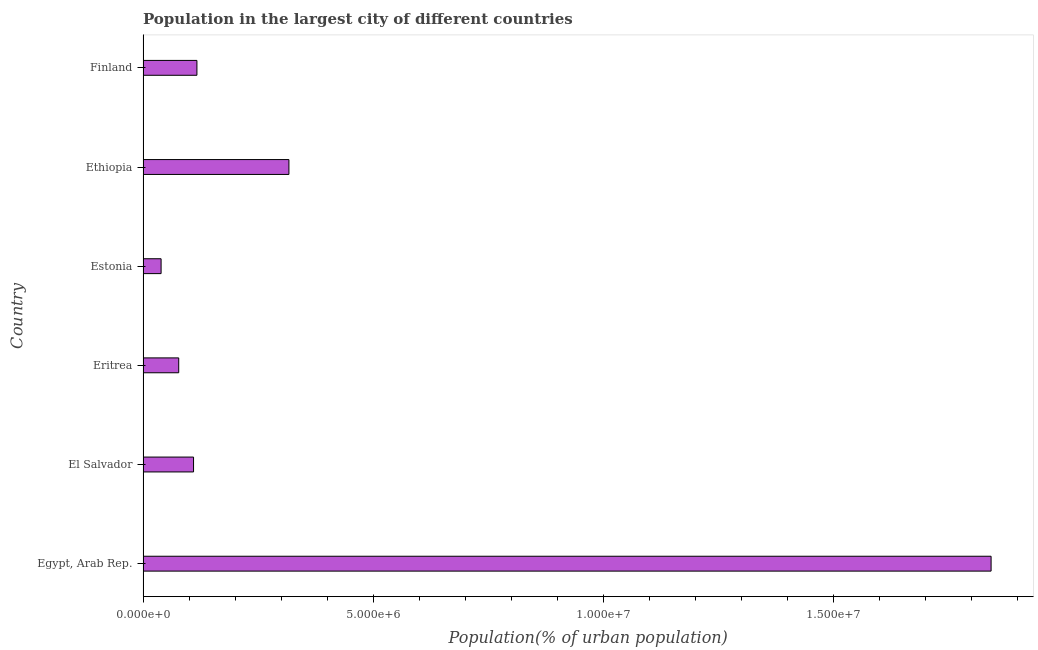Does the graph contain any zero values?
Your answer should be very brief. No. What is the title of the graph?
Your response must be concise. Population in the largest city of different countries. What is the label or title of the X-axis?
Your response must be concise. Population(% of urban population). What is the label or title of the Y-axis?
Keep it short and to the point. Country. What is the population in largest city in El Salvador?
Give a very brief answer. 1.10e+06. Across all countries, what is the maximum population in largest city?
Offer a very short reply. 1.84e+07. Across all countries, what is the minimum population in largest city?
Provide a short and direct response. 3.92e+05. In which country was the population in largest city maximum?
Offer a terse response. Egypt, Arab Rep. In which country was the population in largest city minimum?
Offer a very short reply. Estonia. What is the sum of the population in largest city?
Provide a succinct answer. 2.50e+07. What is the difference between the population in largest city in Egypt, Arab Rep. and El Salvador?
Give a very brief answer. 1.73e+07. What is the average population in largest city per country?
Offer a terse response. 4.17e+06. What is the median population in largest city?
Provide a succinct answer. 1.13e+06. What is the ratio of the population in largest city in Estonia to that in Ethiopia?
Your response must be concise. 0.12. Is the difference between the population in largest city in Egypt, Arab Rep. and Estonia greater than the difference between any two countries?
Keep it short and to the point. Yes. What is the difference between the highest and the second highest population in largest city?
Your response must be concise. 1.53e+07. What is the difference between the highest and the lowest population in largest city?
Keep it short and to the point. 1.80e+07. What is the difference between two consecutive major ticks on the X-axis?
Your response must be concise. 5.00e+06. What is the Population(% of urban population) in Egypt, Arab Rep.?
Your answer should be compact. 1.84e+07. What is the Population(% of urban population) in El Salvador?
Your answer should be compact. 1.10e+06. What is the Population(% of urban population) in Eritrea?
Make the answer very short. 7.75e+05. What is the Population(% of urban population) of Estonia?
Keep it short and to the point. 3.92e+05. What is the Population(% of urban population) in Ethiopia?
Your answer should be very brief. 3.17e+06. What is the Population(% of urban population) in Finland?
Give a very brief answer. 1.17e+06. What is the difference between the Population(% of urban population) in Egypt, Arab Rep. and El Salvador?
Ensure brevity in your answer.  1.73e+07. What is the difference between the Population(% of urban population) in Egypt, Arab Rep. and Eritrea?
Give a very brief answer. 1.76e+07. What is the difference between the Population(% of urban population) in Egypt, Arab Rep. and Estonia?
Make the answer very short. 1.80e+07. What is the difference between the Population(% of urban population) in Egypt, Arab Rep. and Ethiopia?
Keep it short and to the point. 1.53e+07. What is the difference between the Population(% of urban population) in Egypt, Arab Rep. and Finland?
Your answer should be compact. 1.72e+07. What is the difference between the Population(% of urban population) in El Salvador and Eritrea?
Ensure brevity in your answer.  3.22e+05. What is the difference between the Population(% of urban population) in El Salvador and Estonia?
Make the answer very short. 7.05e+05. What is the difference between the Population(% of urban population) in El Salvador and Ethiopia?
Your response must be concise. -2.07e+06. What is the difference between the Population(% of urban population) in El Salvador and Finland?
Your answer should be compact. -7.34e+04. What is the difference between the Population(% of urban population) in Eritrea and Estonia?
Your response must be concise. 3.83e+05. What is the difference between the Population(% of urban population) in Eritrea and Ethiopia?
Make the answer very short. -2.39e+06. What is the difference between the Population(% of urban population) in Eritrea and Finland?
Your answer should be compact. -3.95e+05. What is the difference between the Population(% of urban population) in Estonia and Ethiopia?
Your answer should be compact. -2.78e+06. What is the difference between the Population(% of urban population) in Estonia and Finland?
Ensure brevity in your answer.  -7.78e+05. What is the difference between the Population(% of urban population) in Ethiopia and Finland?
Provide a succinct answer. 2.00e+06. What is the ratio of the Population(% of urban population) in Egypt, Arab Rep. to that in El Salvador?
Your answer should be very brief. 16.8. What is the ratio of the Population(% of urban population) in Egypt, Arab Rep. to that in Eritrea?
Make the answer very short. 23.78. What is the ratio of the Population(% of urban population) in Egypt, Arab Rep. to that in Estonia?
Your answer should be compact. 47.02. What is the ratio of the Population(% of urban population) in Egypt, Arab Rep. to that in Ethiopia?
Offer a very short reply. 5.81. What is the ratio of the Population(% of urban population) in Egypt, Arab Rep. to that in Finland?
Offer a very short reply. 15.74. What is the ratio of the Population(% of urban population) in El Salvador to that in Eritrea?
Your answer should be very brief. 1.42. What is the ratio of the Population(% of urban population) in El Salvador to that in Estonia?
Provide a succinct answer. 2.8. What is the ratio of the Population(% of urban population) in El Salvador to that in Ethiopia?
Provide a short and direct response. 0.35. What is the ratio of the Population(% of urban population) in El Salvador to that in Finland?
Keep it short and to the point. 0.94. What is the ratio of the Population(% of urban population) in Eritrea to that in Estonia?
Make the answer very short. 1.98. What is the ratio of the Population(% of urban population) in Eritrea to that in Ethiopia?
Offer a very short reply. 0.24. What is the ratio of the Population(% of urban population) in Eritrea to that in Finland?
Give a very brief answer. 0.66. What is the ratio of the Population(% of urban population) in Estonia to that in Ethiopia?
Your answer should be compact. 0.12. What is the ratio of the Population(% of urban population) in Estonia to that in Finland?
Your answer should be very brief. 0.34. What is the ratio of the Population(% of urban population) in Ethiopia to that in Finland?
Provide a short and direct response. 2.71. 